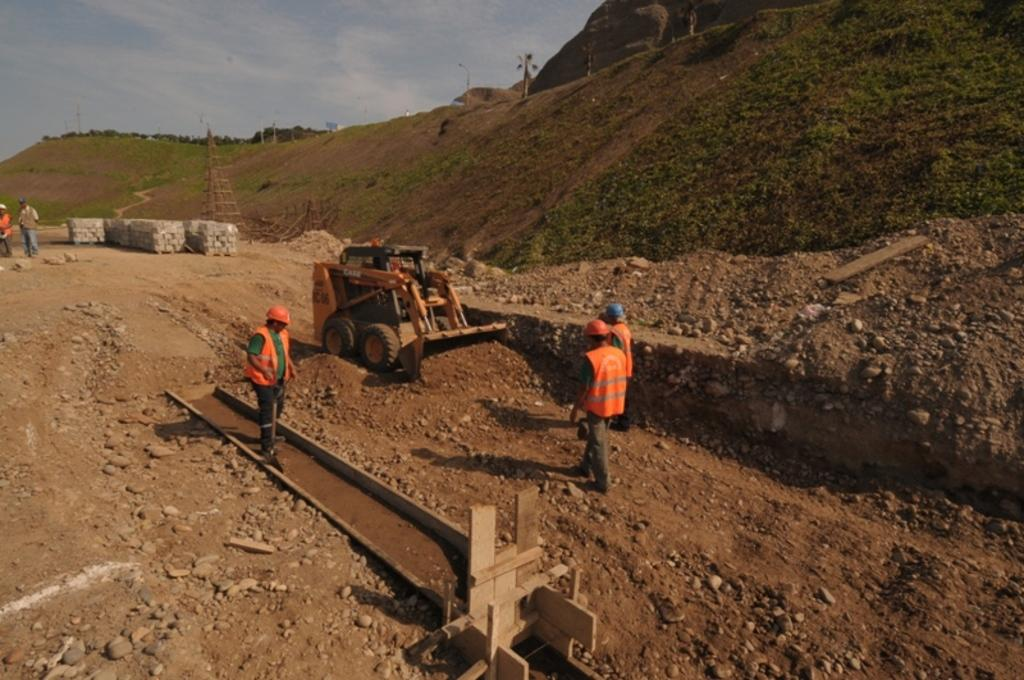What can be seen in the foreground of the image? There are people, an object, and a vehicle in the foreground of the image. What is visible in the background of the image? There are mountains, a tower, poles, and people in the background of the image. Additionally, the sky is visible in the background. What type of sponge is being used by the people in the image? There is no sponge present in the image. What is the title of the image? The image does not have a title, as it is a photograph or illustration and not a piece of literature or artwork with a specific title. 